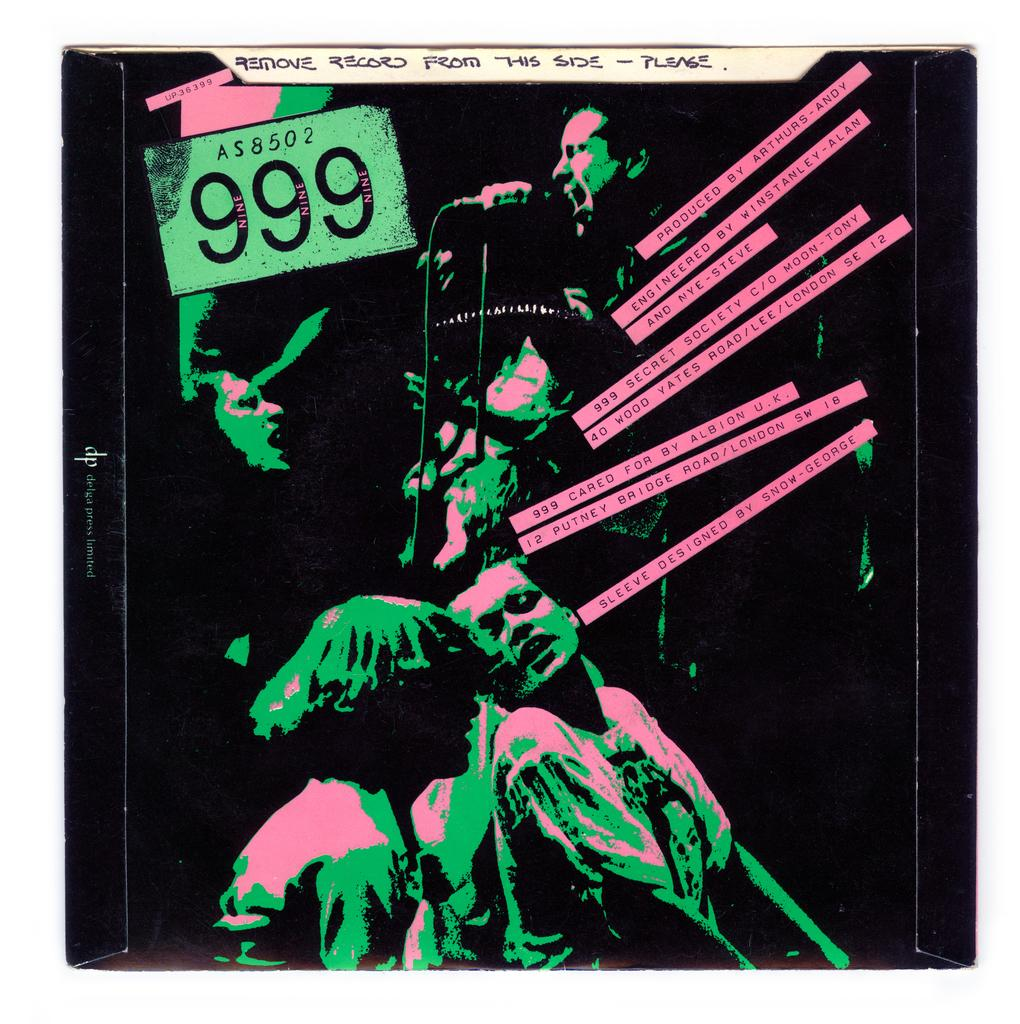<image>
Share a concise interpretation of the image provided. A record album cover features a black, green, and pink image and was produced by Arthurs-Andy. 